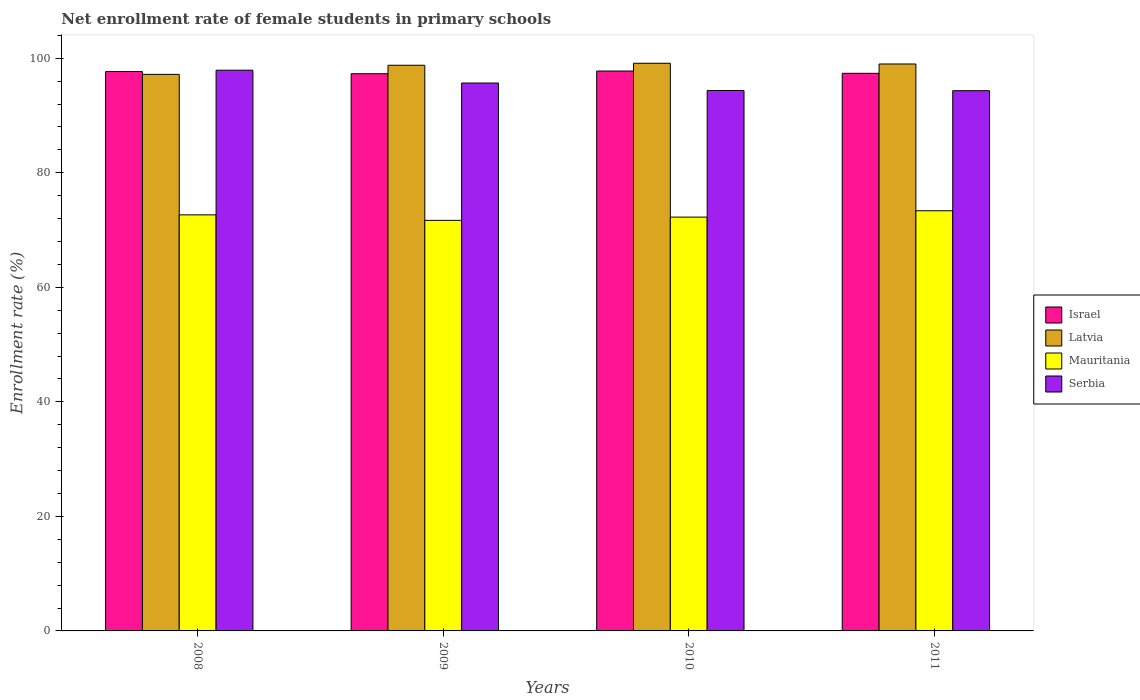How many different coloured bars are there?
Make the answer very short. 4. Are the number of bars per tick equal to the number of legend labels?
Your response must be concise. Yes. How many bars are there on the 2nd tick from the right?
Your answer should be very brief. 4. What is the label of the 2nd group of bars from the left?
Give a very brief answer. 2009. What is the net enrollment rate of female students in primary schools in Serbia in 2010?
Give a very brief answer. 94.38. Across all years, what is the maximum net enrollment rate of female students in primary schools in Serbia?
Your answer should be compact. 97.92. Across all years, what is the minimum net enrollment rate of female students in primary schools in Mauritania?
Offer a terse response. 71.69. In which year was the net enrollment rate of female students in primary schools in Israel minimum?
Make the answer very short. 2009. What is the total net enrollment rate of female students in primary schools in Israel in the graph?
Offer a very short reply. 390.13. What is the difference between the net enrollment rate of female students in primary schools in Israel in 2008 and that in 2011?
Give a very brief answer. 0.31. What is the difference between the net enrollment rate of female students in primary schools in Latvia in 2011 and the net enrollment rate of female students in primary schools in Serbia in 2009?
Your response must be concise. 3.32. What is the average net enrollment rate of female students in primary schools in Israel per year?
Your response must be concise. 97.53. In the year 2011, what is the difference between the net enrollment rate of female students in primary schools in Mauritania and net enrollment rate of female students in primary schools in Israel?
Ensure brevity in your answer.  -24. What is the ratio of the net enrollment rate of female students in primary schools in Latvia in 2008 to that in 2011?
Give a very brief answer. 0.98. Is the difference between the net enrollment rate of female students in primary schools in Mauritania in 2009 and 2011 greater than the difference between the net enrollment rate of female students in primary schools in Israel in 2009 and 2011?
Your response must be concise. No. What is the difference between the highest and the second highest net enrollment rate of female students in primary schools in Mauritania?
Provide a short and direct response. 0.71. What is the difference between the highest and the lowest net enrollment rate of female students in primary schools in Serbia?
Give a very brief answer. 3.58. What does the 1st bar from the left in 2008 represents?
Provide a short and direct response. Israel. What does the 4th bar from the right in 2011 represents?
Your answer should be compact. Israel. Is it the case that in every year, the sum of the net enrollment rate of female students in primary schools in Latvia and net enrollment rate of female students in primary schools in Israel is greater than the net enrollment rate of female students in primary schools in Mauritania?
Your answer should be very brief. Yes. How many bars are there?
Make the answer very short. 16. How many years are there in the graph?
Provide a succinct answer. 4. Are the values on the major ticks of Y-axis written in scientific E-notation?
Ensure brevity in your answer.  No. Does the graph contain grids?
Provide a succinct answer. No. What is the title of the graph?
Your answer should be compact. Net enrollment rate of female students in primary schools. What is the label or title of the X-axis?
Provide a short and direct response. Years. What is the label or title of the Y-axis?
Your answer should be very brief. Enrollment rate (%). What is the Enrollment rate (%) of Israel in 2008?
Make the answer very short. 97.68. What is the Enrollment rate (%) of Latvia in 2008?
Offer a terse response. 97.19. What is the Enrollment rate (%) in Mauritania in 2008?
Offer a very short reply. 72.66. What is the Enrollment rate (%) in Serbia in 2008?
Offer a terse response. 97.92. What is the Enrollment rate (%) of Israel in 2009?
Keep it short and to the point. 97.3. What is the Enrollment rate (%) of Latvia in 2009?
Offer a terse response. 98.78. What is the Enrollment rate (%) in Mauritania in 2009?
Ensure brevity in your answer.  71.69. What is the Enrollment rate (%) in Serbia in 2009?
Offer a terse response. 95.68. What is the Enrollment rate (%) in Israel in 2010?
Provide a succinct answer. 97.77. What is the Enrollment rate (%) in Latvia in 2010?
Keep it short and to the point. 99.13. What is the Enrollment rate (%) in Mauritania in 2010?
Your answer should be compact. 72.26. What is the Enrollment rate (%) of Serbia in 2010?
Your response must be concise. 94.38. What is the Enrollment rate (%) in Israel in 2011?
Your response must be concise. 97.37. What is the Enrollment rate (%) in Latvia in 2011?
Offer a terse response. 99. What is the Enrollment rate (%) of Mauritania in 2011?
Give a very brief answer. 73.37. What is the Enrollment rate (%) in Serbia in 2011?
Your answer should be very brief. 94.34. Across all years, what is the maximum Enrollment rate (%) of Israel?
Keep it short and to the point. 97.77. Across all years, what is the maximum Enrollment rate (%) of Latvia?
Your answer should be very brief. 99.13. Across all years, what is the maximum Enrollment rate (%) of Mauritania?
Provide a succinct answer. 73.37. Across all years, what is the maximum Enrollment rate (%) of Serbia?
Offer a very short reply. 97.92. Across all years, what is the minimum Enrollment rate (%) of Israel?
Keep it short and to the point. 97.3. Across all years, what is the minimum Enrollment rate (%) of Latvia?
Provide a short and direct response. 97.19. Across all years, what is the minimum Enrollment rate (%) of Mauritania?
Your response must be concise. 71.69. Across all years, what is the minimum Enrollment rate (%) in Serbia?
Offer a terse response. 94.34. What is the total Enrollment rate (%) of Israel in the graph?
Provide a short and direct response. 390.13. What is the total Enrollment rate (%) in Latvia in the graph?
Offer a terse response. 394.09. What is the total Enrollment rate (%) in Mauritania in the graph?
Provide a short and direct response. 289.98. What is the total Enrollment rate (%) of Serbia in the graph?
Offer a very short reply. 382.3. What is the difference between the Enrollment rate (%) of Israel in 2008 and that in 2009?
Provide a short and direct response. 0.38. What is the difference between the Enrollment rate (%) in Latvia in 2008 and that in 2009?
Ensure brevity in your answer.  -1.59. What is the difference between the Enrollment rate (%) of Mauritania in 2008 and that in 2009?
Provide a succinct answer. 0.96. What is the difference between the Enrollment rate (%) of Serbia in 2008 and that in 2009?
Make the answer very short. 2.24. What is the difference between the Enrollment rate (%) of Israel in 2008 and that in 2010?
Offer a very short reply. -0.09. What is the difference between the Enrollment rate (%) in Latvia in 2008 and that in 2010?
Your answer should be compact. -1.94. What is the difference between the Enrollment rate (%) in Mauritania in 2008 and that in 2010?
Your answer should be compact. 0.4. What is the difference between the Enrollment rate (%) of Serbia in 2008 and that in 2010?
Provide a succinct answer. 3.54. What is the difference between the Enrollment rate (%) in Israel in 2008 and that in 2011?
Give a very brief answer. 0.31. What is the difference between the Enrollment rate (%) of Latvia in 2008 and that in 2011?
Provide a short and direct response. -1.81. What is the difference between the Enrollment rate (%) of Mauritania in 2008 and that in 2011?
Provide a short and direct response. -0.71. What is the difference between the Enrollment rate (%) in Serbia in 2008 and that in 2011?
Provide a succinct answer. 3.58. What is the difference between the Enrollment rate (%) in Israel in 2009 and that in 2010?
Keep it short and to the point. -0.47. What is the difference between the Enrollment rate (%) in Latvia in 2009 and that in 2010?
Your answer should be compact. -0.35. What is the difference between the Enrollment rate (%) in Mauritania in 2009 and that in 2010?
Provide a short and direct response. -0.57. What is the difference between the Enrollment rate (%) in Serbia in 2009 and that in 2010?
Provide a short and direct response. 1.3. What is the difference between the Enrollment rate (%) in Israel in 2009 and that in 2011?
Your answer should be very brief. -0.07. What is the difference between the Enrollment rate (%) of Latvia in 2009 and that in 2011?
Your answer should be very brief. -0.22. What is the difference between the Enrollment rate (%) in Mauritania in 2009 and that in 2011?
Provide a short and direct response. -1.68. What is the difference between the Enrollment rate (%) in Serbia in 2009 and that in 2011?
Keep it short and to the point. 1.34. What is the difference between the Enrollment rate (%) of Israel in 2010 and that in 2011?
Keep it short and to the point. 0.4. What is the difference between the Enrollment rate (%) of Latvia in 2010 and that in 2011?
Your response must be concise. 0.13. What is the difference between the Enrollment rate (%) in Mauritania in 2010 and that in 2011?
Provide a short and direct response. -1.11. What is the difference between the Enrollment rate (%) of Serbia in 2010 and that in 2011?
Your answer should be compact. 0.04. What is the difference between the Enrollment rate (%) of Israel in 2008 and the Enrollment rate (%) of Latvia in 2009?
Ensure brevity in your answer.  -1.09. What is the difference between the Enrollment rate (%) of Israel in 2008 and the Enrollment rate (%) of Mauritania in 2009?
Keep it short and to the point. 25.99. What is the difference between the Enrollment rate (%) of Israel in 2008 and the Enrollment rate (%) of Serbia in 2009?
Give a very brief answer. 2.01. What is the difference between the Enrollment rate (%) in Latvia in 2008 and the Enrollment rate (%) in Mauritania in 2009?
Your response must be concise. 25.5. What is the difference between the Enrollment rate (%) in Latvia in 2008 and the Enrollment rate (%) in Serbia in 2009?
Your response must be concise. 1.51. What is the difference between the Enrollment rate (%) of Mauritania in 2008 and the Enrollment rate (%) of Serbia in 2009?
Ensure brevity in your answer.  -23.02. What is the difference between the Enrollment rate (%) in Israel in 2008 and the Enrollment rate (%) in Latvia in 2010?
Give a very brief answer. -1.44. What is the difference between the Enrollment rate (%) in Israel in 2008 and the Enrollment rate (%) in Mauritania in 2010?
Offer a terse response. 25.42. What is the difference between the Enrollment rate (%) in Israel in 2008 and the Enrollment rate (%) in Serbia in 2010?
Your answer should be very brief. 3.31. What is the difference between the Enrollment rate (%) in Latvia in 2008 and the Enrollment rate (%) in Mauritania in 2010?
Offer a very short reply. 24.93. What is the difference between the Enrollment rate (%) of Latvia in 2008 and the Enrollment rate (%) of Serbia in 2010?
Keep it short and to the point. 2.81. What is the difference between the Enrollment rate (%) in Mauritania in 2008 and the Enrollment rate (%) in Serbia in 2010?
Your answer should be compact. -21.72. What is the difference between the Enrollment rate (%) of Israel in 2008 and the Enrollment rate (%) of Latvia in 2011?
Your response must be concise. -1.31. What is the difference between the Enrollment rate (%) in Israel in 2008 and the Enrollment rate (%) in Mauritania in 2011?
Your answer should be compact. 24.31. What is the difference between the Enrollment rate (%) in Israel in 2008 and the Enrollment rate (%) in Serbia in 2011?
Offer a terse response. 3.35. What is the difference between the Enrollment rate (%) in Latvia in 2008 and the Enrollment rate (%) in Mauritania in 2011?
Offer a terse response. 23.82. What is the difference between the Enrollment rate (%) in Latvia in 2008 and the Enrollment rate (%) in Serbia in 2011?
Provide a succinct answer. 2.85. What is the difference between the Enrollment rate (%) in Mauritania in 2008 and the Enrollment rate (%) in Serbia in 2011?
Make the answer very short. -21.68. What is the difference between the Enrollment rate (%) in Israel in 2009 and the Enrollment rate (%) in Latvia in 2010?
Provide a succinct answer. -1.83. What is the difference between the Enrollment rate (%) of Israel in 2009 and the Enrollment rate (%) of Mauritania in 2010?
Your answer should be very brief. 25.04. What is the difference between the Enrollment rate (%) in Israel in 2009 and the Enrollment rate (%) in Serbia in 2010?
Provide a succinct answer. 2.92. What is the difference between the Enrollment rate (%) in Latvia in 2009 and the Enrollment rate (%) in Mauritania in 2010?
Your answer should be very brief. 26.52. What is the difference between the Enrollment rate (%) of Latvia in 2009 and the Enrollment rate (%) of Serbia in 2010?
Provide a short and direct response. 4.4. What is the difference between the Enrollment rate (%) of Mauritania in 2009 and the Enrollment rate (%) of Serbia in 2010?
Provide a short and direct response. -22.68. What is the difference between the Enrollment rate (%) of Israel in 2009 and the Enrollment rate (%) of Latvia in 2011?
Your answer should be compact. -1.7. What is the difference between the Enrollment rate (%) in Israel in 2009 and the Enrollment rate (%) in Mauritania in 2011?
Ensure brevity in your answer.  23.93. What is the difference between the Enrollment rate (%) in Israel in 2009 and the Enrollment rate (%) in Serbia in 2011?
Offer a very short reply. 2.96. What is the difference between the Enrollment rate (%) in Latvia in 2009 and the Enrollment rate (%) in Mauritania in 2011?
Your answer should be very brief. 25.41. What is the difference between the Enrollment rate (%) of Latvia in 2009 and the Enrollment rate (%) of Serbia in 2011?
Offer a very short reply. 4.44. What is the difference between the Enrollment rate (%) of Mauritania in 2009 and the Enrollment rate (%) of Serbia in 2011?
Your answer should be compact. -22.65. What is the difference between the Enrollment rate (%) of Israel in 2010 and the Enrollment rate (%) of Latvia in 2011?
Provide a succinct answer. -1.23. What is the difference between the Enrollment rate (%) of Israel in 2010 and the Enrollment rate (%) of Mauritania in 2011?
Ensure brevity in your answer.  24.4. What is the difference between the Enrollment rate (%) in Israel in 2010 and the Enrollment rate (%) in Serbia in 2011?
Ensure brevity in your answer.  3.43. What is the difference between the Enrollment rate (%) of Latvia in 2010 and the Enrollment rate (%) of Mauritania in 2011?
Give a very brief answer. 25.76. What is the difference between the Enrollment rate (%) of Latvia in 2010 and the Enrollment rate (%) of Serbia in 2011?
Ensure brevity in your answer.  4.79. What is the difference between the Enrollment rate (%) in Mauritania in 2010 and the Enrollment rate (%) in Serbia in 2011?
Offer a very short reply. -22.08. What is the average Enrollment rate (%) in Israel per year?
Ensure brevity in your answer.  97.53. What is the average Enrollment rate (%) of Latvia per year?
Your response must be concise. 98.52. What is the average Enrollment rate (%) in Mauritania per year?
Keep it short and to the point. 72.49. What is the average Enrollment rate (%) in Serbia per year?
Offer a terse response. 95.58. In the year 2008, what is the difference between the Enrollment rate (%) in Israel and Enrollment rate (%) in Latvia?
Keep it short and to the point. 0.5. In the year 2008, what is the difference between the Enrollment rate (%) of Israel and Enrollment rate (%) of Mauritania?
Your answer should be very brief. 25.03. In the year 2008, what is the difference between the Enrollment rate (%) of Israel and Enrollment rate (%) of Serbia?
Your answer should be very brief. -0.23. In the year 2008, what is the difference between the Enrollment rate (%) of Latvia and Enrollment rate (%) of Mauritania?
Make the answer very short. 24.53. In the year 2008, what is the difference between the Enrollment rate (%) in Latvia and Enrollment rate (%) in Serbia?
Keep it short and to the point. -0.73. In the year 2008, what is the difference between the Enrollment rate (%) of Mauritania and Enrollment rate (%) of Serbia?
Give a very brief answer. -25.26. In the year 2009, what is the difference between the Enrollment rate (%) of Israel and Enrollment rate (%) of Latvia?
Provide a succinct answer. -1.48. In the year 2009, what is the difference between the Enrollment rate (%) in Israel and Enrollment rate (%) in Mauritania?
Your answer should be compact. 25.61. In the year 2009, what is the difference between the Enrollment rate (%) of Israel and Enrollment rate (%) of Serbia?
Your answer should be very brief. 1.62. In the year 2009, what is the difference between the Enrollment rate (%) in Latvia and Enrollment rate (%) in Mauritania?
Offer a very short reply. 27.09. In the year 2009, what is the difference between the Enrollment rate (%) in Latvia and Enrollment rate (%) in Serbia?
Ensure brevity in your answer.  3.1. In the year 2009, what is the difference between the Enrollment rate (%) in Mauritania and Enrollment rate (%) in Serbia?
Keep it short and to the point. -23.99. In the year 2010, what is the difference between the Enrollment rate (%) of Israel and Enrollment rate (%) of Latvia?
Offer a terse response. -1.36. In the year 2010, what is the difference between the Enrollment rate (%) of Israel and Enrollment rate (%) of Mauritania?
Your answer should be compact. 25.51. In the year 2010, what is the difference between the Enrollment rate (%) in Israel and Enrollment rate (%) in Serbia?
Offer a terse response. 3.4. In the year 2010, what is the difference between the Enrollment rate (%) in Latvia and Enrollment rate (%) in Mauritania?
Keep it short and to the point. 26.87. In the year 2010, what is the difference between the Enrollment rate (%) of Latvia and Enrollment rate (%) of Serbia?
Your answer should be very brief. 4.75. In the year 2010, what is the difference between the Enrollment rate (%) of Mauritania and Enrollment rate (%) of Serbia?
Your answer should be compact. -22.12. In the year 2011, what is the difference between the Enrollment rate (%) of Israel and Enrollment rate (%) of Latvia?
Your answer should be very brief. -1.63. In the year 2011, what is the difference between the Enrollment rate (%) of Israel and Enrollment rate (%) of Mauritania?
Your answer should be very brief. 24. In the year 2011, what is the difference between the Enrollment rate (%) in Israel and Enrollment rate (%) in Serbia?
Ensure brevity in your answer.  3.03. In the year 2011, what is the difference between the Enrollment rate (%) in Latvia and Enrollment rate (%) in Mauritania?
Provide a short and direct response. 25.63. In the year 2011, what is the difference between the Enrollment rate (%) in Latvia and Enrollment rate (%) in Serbia?
Provide a succinct answer. 4.66. In the year 2011, what is the difference between the Enrollment rate (%) of Mauritania and Enrollment rate (%) of Serbia?
Offer a very short reply. -20.97. What is the ratio of the Enrollment rate (%) of Latvia in 2008 to that in 2009?
Give a very brief answer. 0.98. What is the ratio of the Enrollment rate (%) of Mauritania in 2008 to that in 2009?
Provide a short and direct response. 1.01. What is the ratio of the Enrollment rate (%) of Serbia in 2008 to that in 2009?
Make the answer very short. 1.02. What is the ratio of the Enrollment rate (%) of Latvia in 2008 to that in 2010?
Your answer should be compact. 0.98. What is the ratio of the Enrollment rate (%) in Serbia in 2008 to that in 2010?
Your answer should be very brief. 1.04. What is the ratio of the Enrollment rate (%) of Israel in 2008 to that in 2011?
Keep it short and to the point. 1. What is the ratio of the Enrollment rate (%) of Latvia in 2008 to that in 2011?
Provide a short and direct response. 0.98. What is the ratio of the Enrollment rate (%) of Mauritania in 2008 to that in 2011?
Provide a succinct answer. 0.99. What is the ratio of the Enrollment rate (%) of Serbia in 2008 to that in 2011?
Ensure brevity in your answer.  1.04. What is the ratio of the Enrollment rate (%) of Israel in 2009 to that in 2010?
Keep it short and to the point. 1. What is the ratio of the Enrollment rate (%) of Mauritania in 2009 to that in 2010?
Offer a terse response. 0.99. What is the ratio of the Enrollment rate (%) of Serbia in 2009 to that in 2010?
Your answer should be very brief. 1.01. What is the ratio of the Enrollment rate (%) of Latvia in 2009 to that in 2011?
Your answer should be compact. 1. What is the ratio of the Enrollment rate (%) in Mauritania in 2009 to that in 2011?
Give a very brief answer. 0.98. What is the ratio of the Enrollment rate (%) of Serbia in 2009 to that in 2011?
Your answer should be very brief. 1.01. What is the ratio of the Enrollment rate (%) in Latvia in 2010 to that in 2011?
Your response must be concise. 1. What is the ratio of the Enrollment rate (%) of Mauritania in 2010 to that in 2011?
Offer a very short reply. 0.98. What is the difference between the highest and the second highest Enrollment rate (%) of Israel?
Ensure brevity in your answer.  0.09. What is the difference between the highest and the second highest Enrollment rate (%) of Latvia?
Ensure brevity in your answer.  0.13. What is the difference between the highest and the second highest Enrollment rate (%) in Mauritania?
Your answer should be very brief. 0.71. What is the difference between the highest and the second highest Enrollment rate (%) of Serbia?
Provide a succinct answer. 2.24. What is the difference between the highest and the lowest Enrollment rate (%) in Israel?
Ensure brevity in your answer.  0.47. What is the difference between the highest and the lowest Enrollment rate (%) of Latvia?
Your answer should be compact. 1.94. What is the difference between the highest and the lowest Enrollment rate (%) of Mauritania?
Offer a very short reply. 1.68. What is the difference between the highest and the lowest Enrollment rate (%) in Serbia?
Keep it short and to the point. 3.58. 